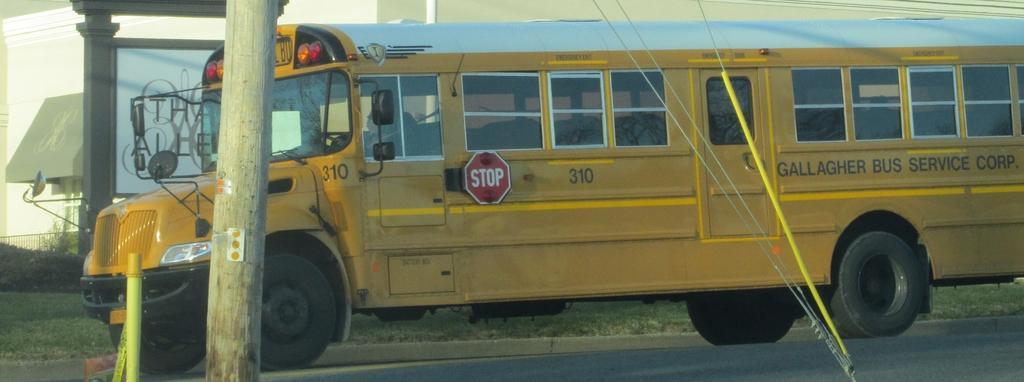Please provide a concise description of this image. In the picture we can see a bus on the road which is yellow in color and on the bus it is written as GALLAGHER BUS SERVICE CORP and in the front near the bus we can see a two pillars on the road. 